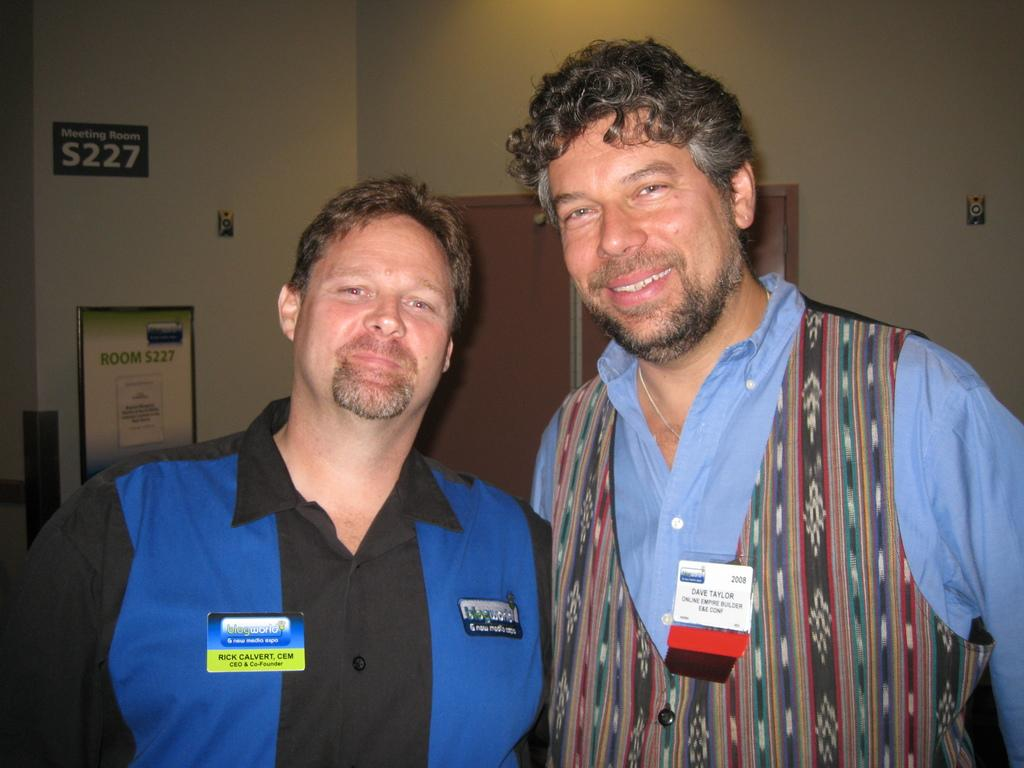How many men are present in the image? There are two men in the image. What are the men doing in the image? The men are seeing and smiling in the image. What can be seen in the background of the image? There are doors, walls, a board, stickers, and some objects in the background of the image. Can you see a kitty playing with a rose in a vase in the image? There is no kitty, rose, or vase present in the image. 